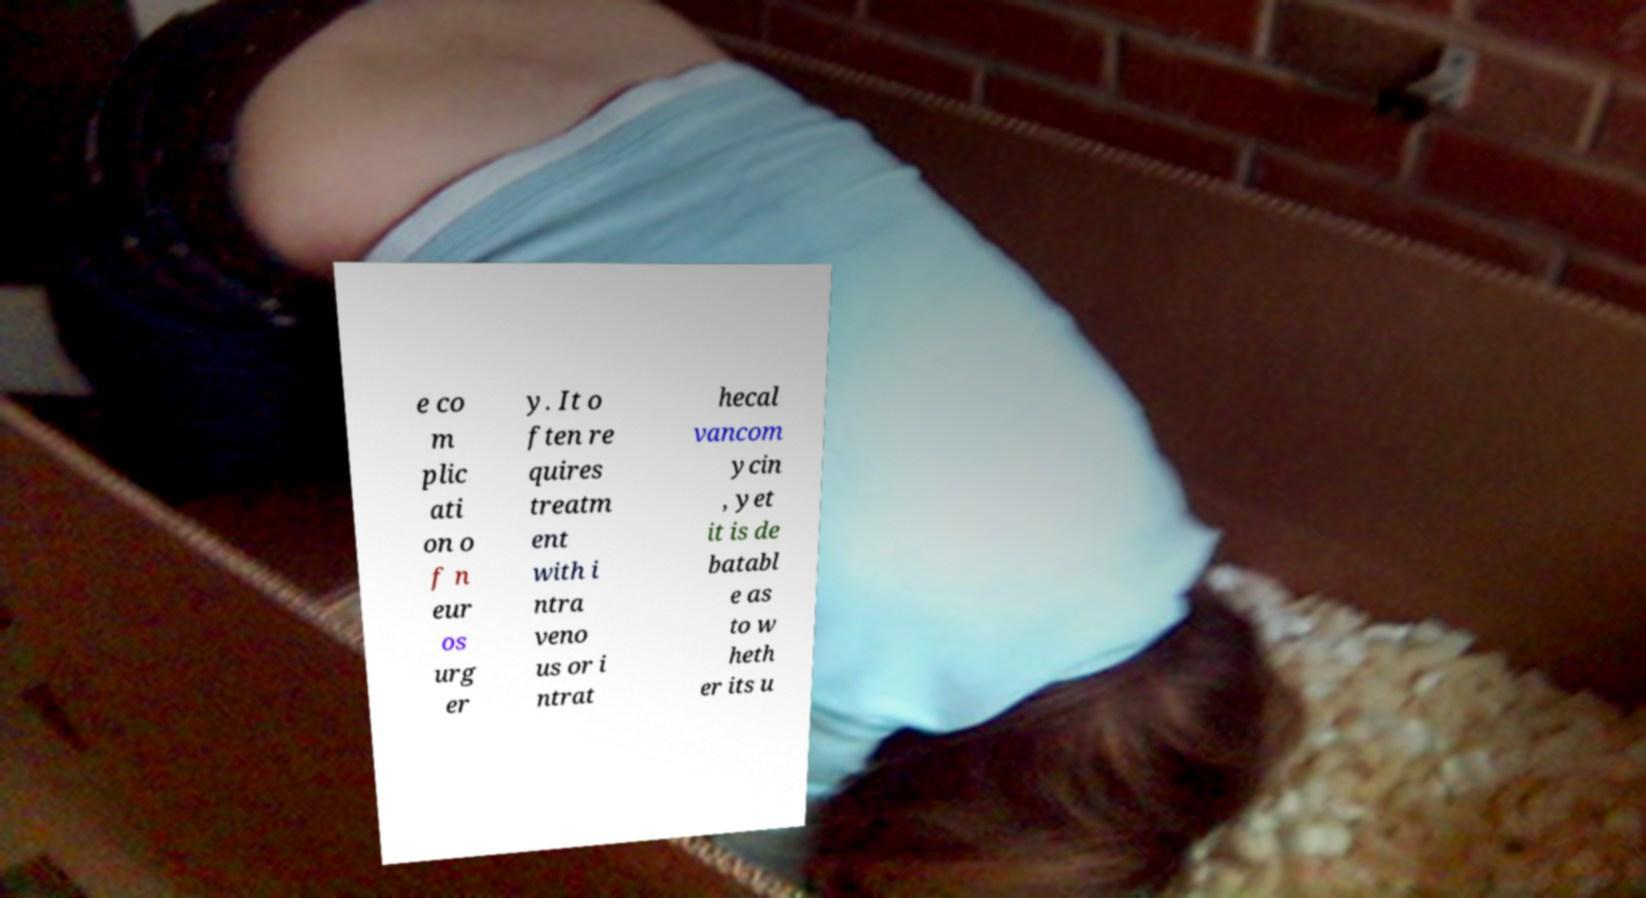What messages or text are displayed in this image? I need them in a readable, typed format. e co m plic ati on o f n eur os urg er y. It o ften re quires treatm ent with i ntra veno us or i ntrat hecal vancom ycin , yet it is de batabl e as to w heth er its u 